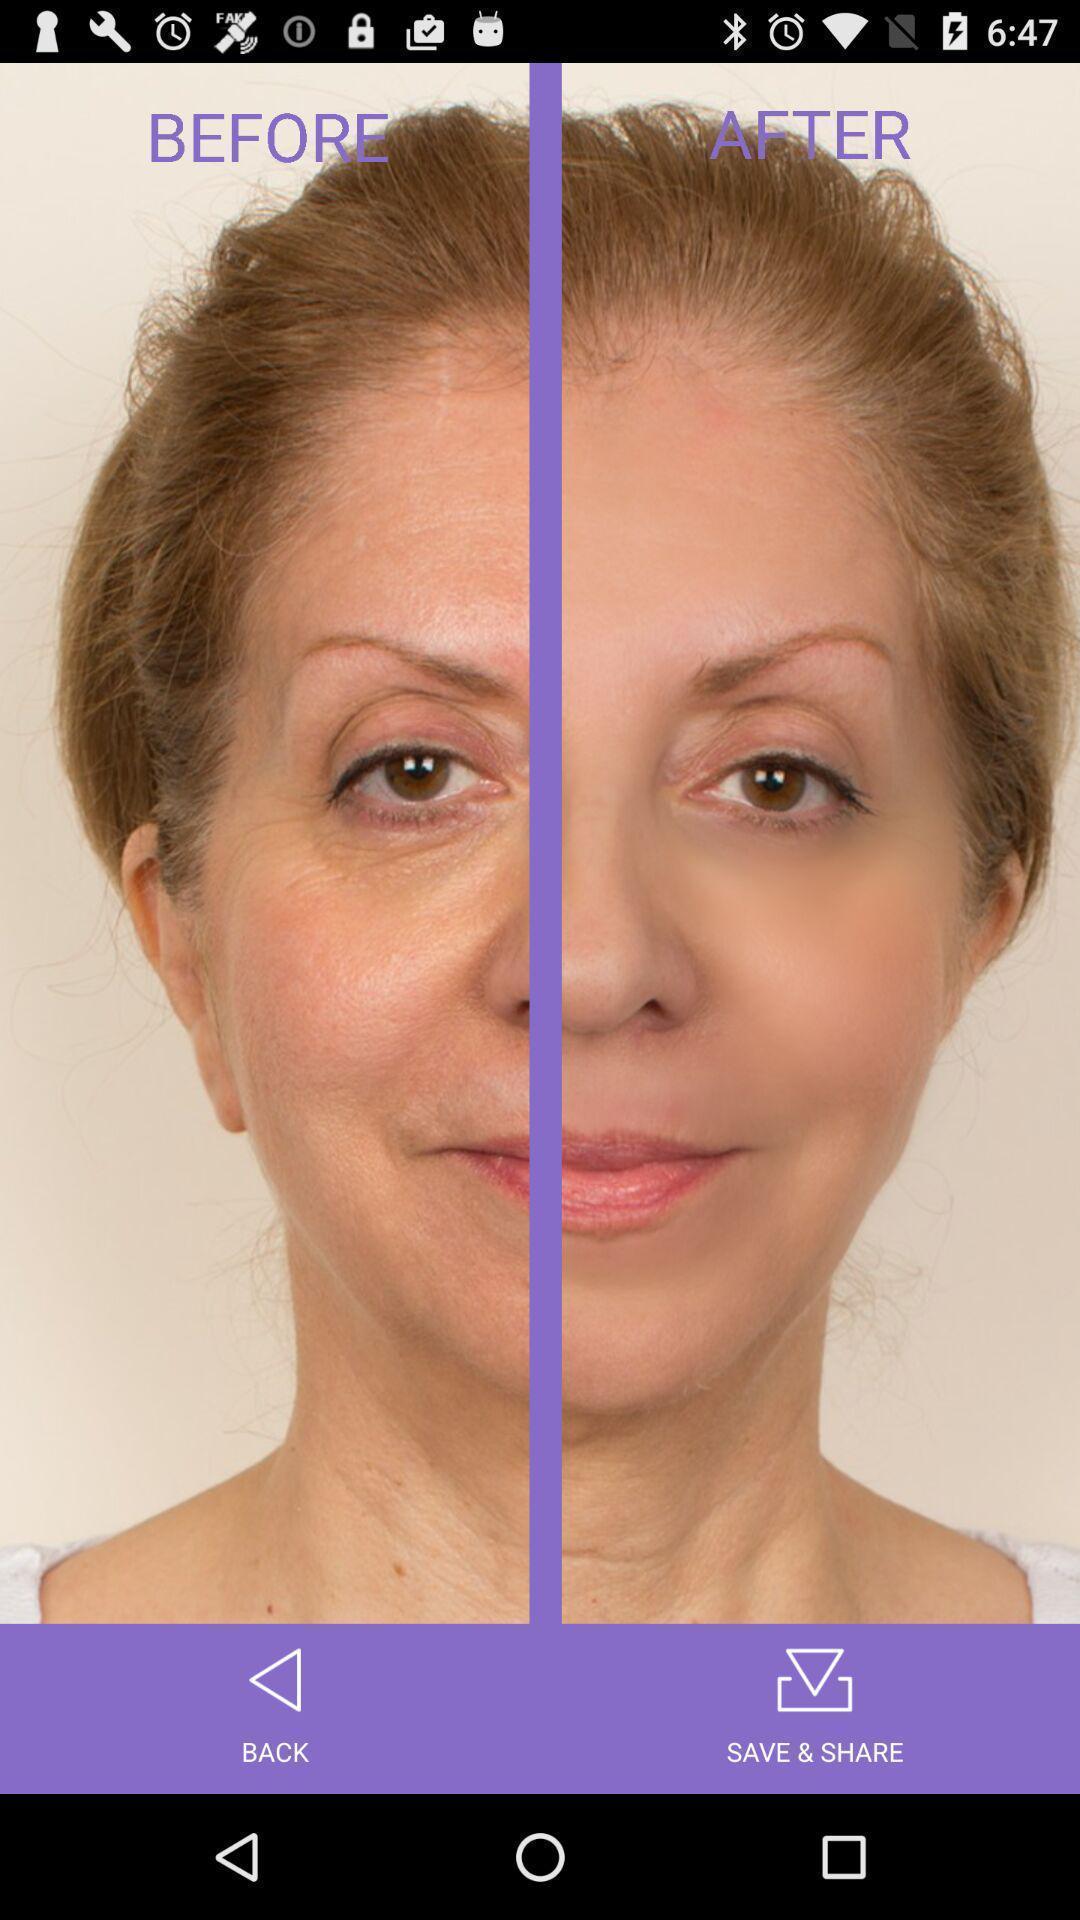What details can you identify in this image? Page showing face image. 